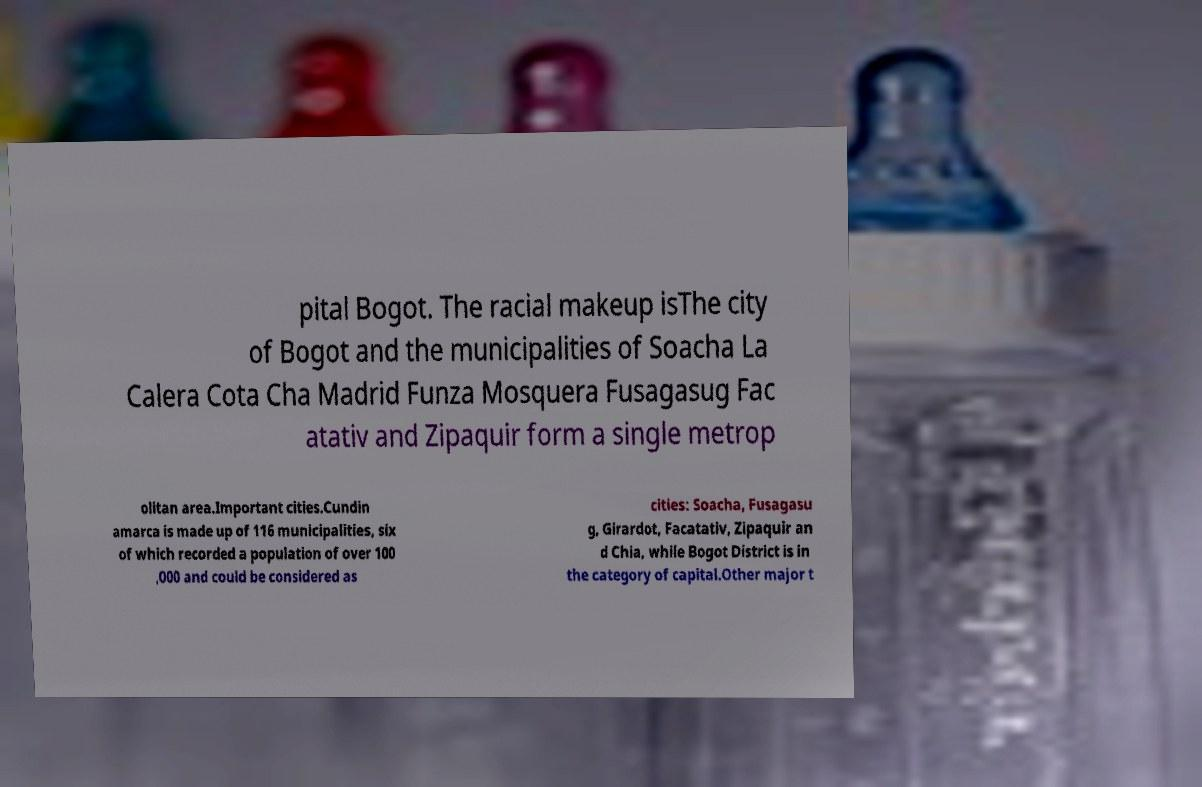Can you accurately transcribe the text from the provided image for me? pital Bogot. The racial makeup isThe city of Bogot and the municipalities of Soacha La Calera Cota Cha Madrid Funza Mosquera Fusagasug Fac atativ and Zipaquir form a single metrop olitan area.Important cities.Cundin amarca is made up of 116 municipalities, six of which recorded a population of over 100 ,000 and could be considered as cities: Soacha, Fusagasu g, Girardot, Facatativ, Zipaquir an d Chia, while Bogot District is in the category of capital.Other major t 